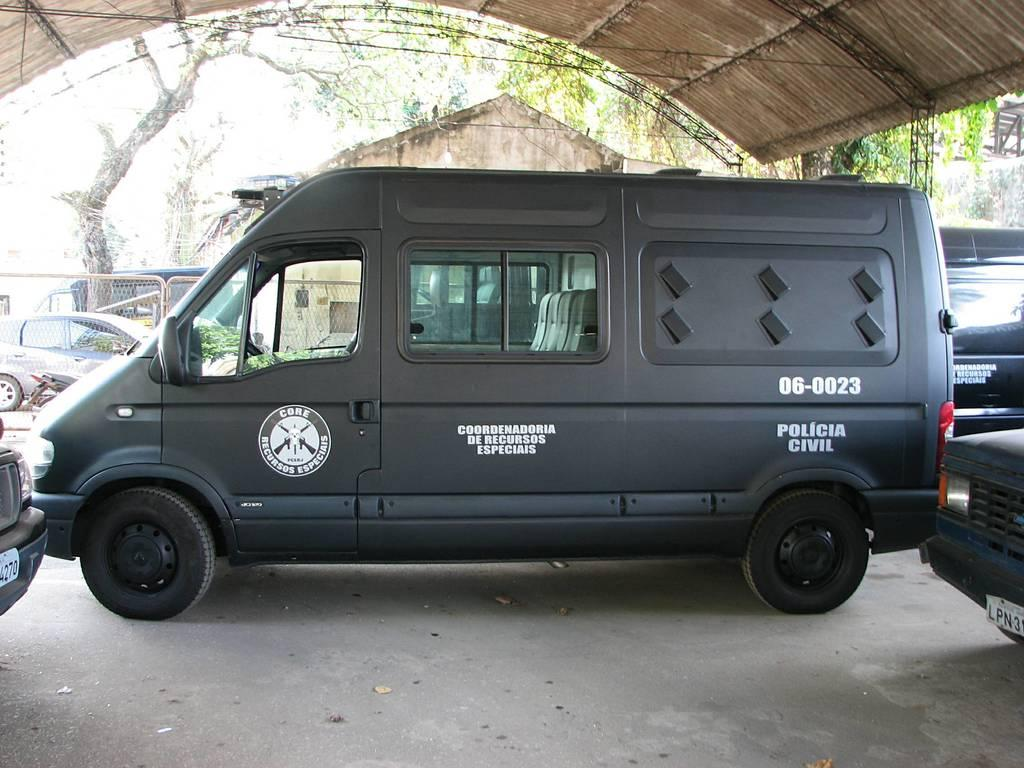Provide a one-sentence caption for the provided image. A black van used by the Policia Civil has the back windows covered up. 